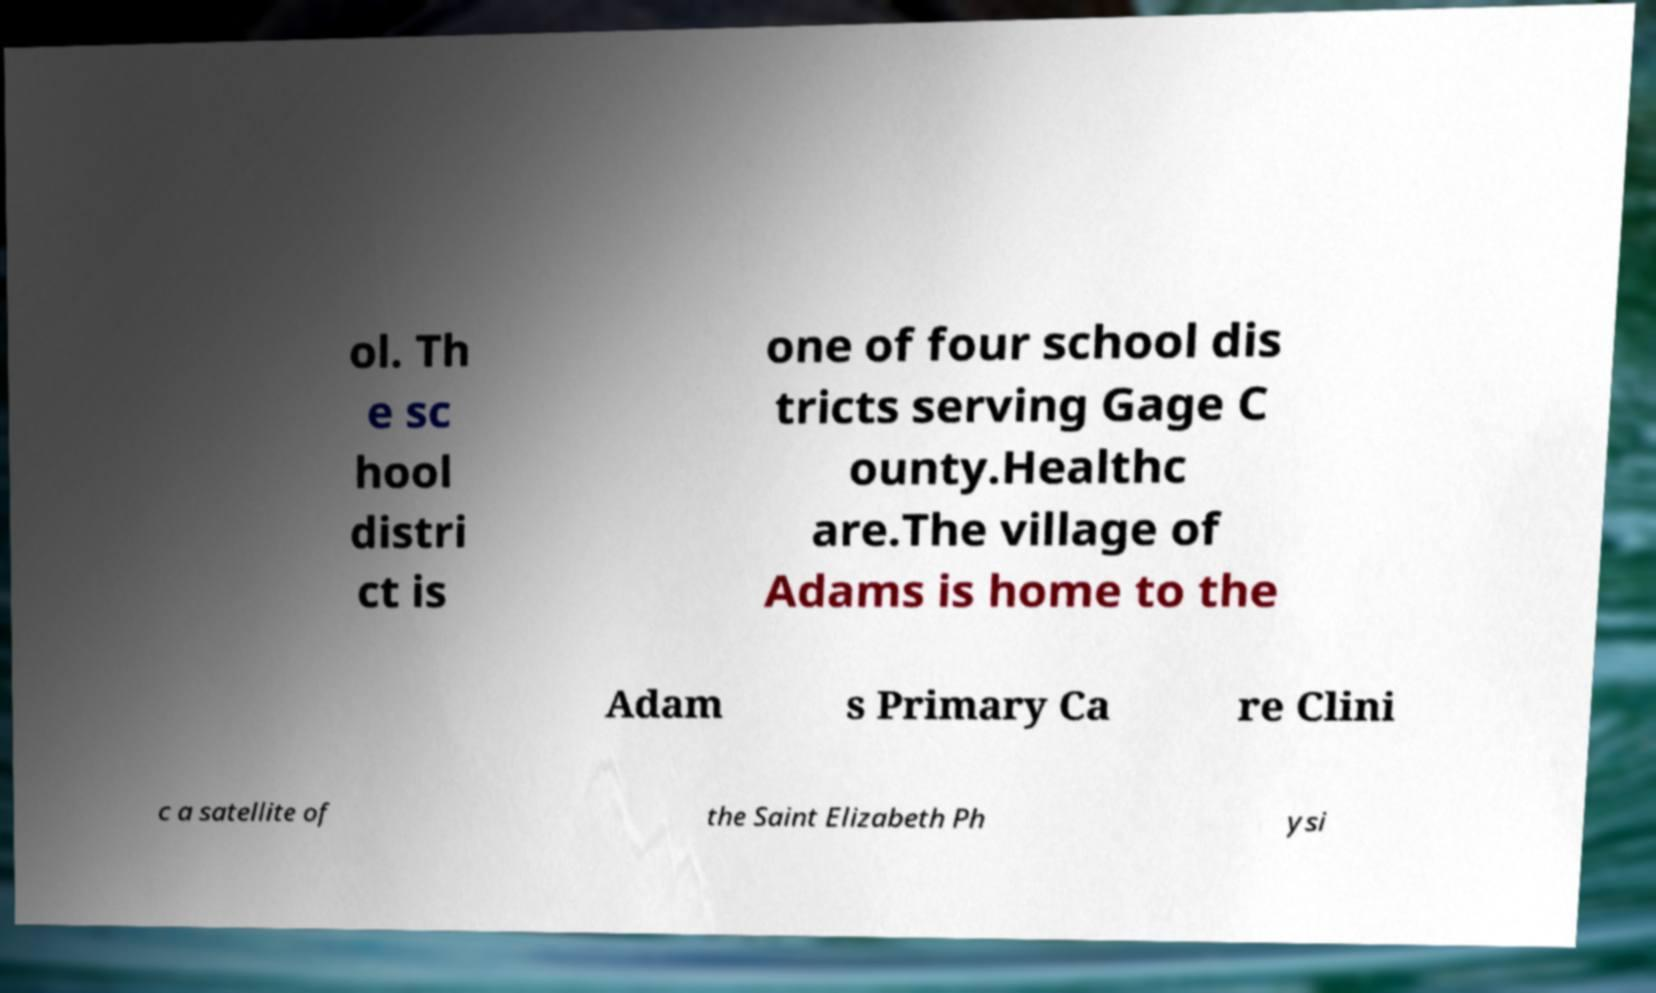Could you extract and type out the text from this image? ol. Th e sc hool distri ct is one of four school dis tricts serving Gage C ounty.Healthc are.The village of Adams is home to the Adam s Primary Ca re Clini c a satellite of the Saint Elizabeth Ph ysi 